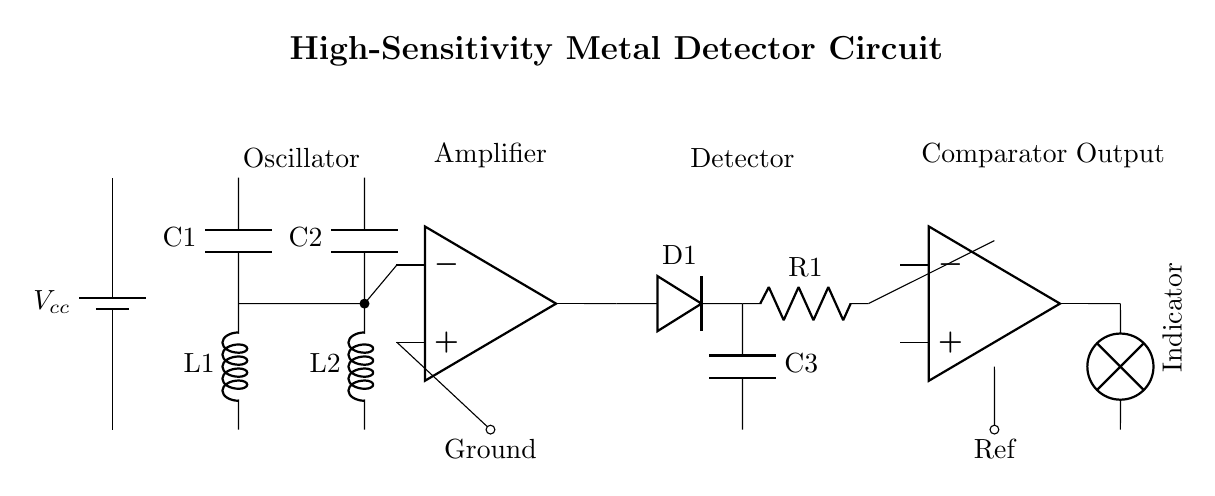What is the primary function of the circuit? The primary function of this circuit is to detect buried metallic artifacts. This is determined by analyzing the components and their arrangement, which are common in metal detection circuits.
Answer: Metal detection What type of amplifier is used in the circuit? The circuit uses an operational amplifier, indicated by the symbol for op amp. This is identified by the respective symbol drawn in the circuit diagram.
Answer: Operational amplifier How many stages are there in the circuit? The circuit has four main stages: oscillator, amplifier, detector, and comparator. By counting the labeled sections in the diagram, we can identify these stages clearly.
Answer: Four What component provides the power to the circuit? The circuit is powered by a battery, marked as Vcc. This can be observed at the start of the circuit diagram where the battery symbol is located.
Answer: Battery At which point does the output occur? The output occurs at the output of the comparator, which is identified in the circuit where the signal exits towards the indicator.
Answer: Comparator output What is the role of the diode in the circuit? The diode serves to detect and rectify the signals from the detector, allowing current to flow in one direction. This can be inferred from its placement after the detector in the circuit.
Answer: Rectification Which component is responsible for indicating the detection of metals? The indicator lamp is responsible for showing whether metals have been detected. This is represented at the end of the circuit where the labeled output connects to a lamp.
Answer: Indicator lamp 